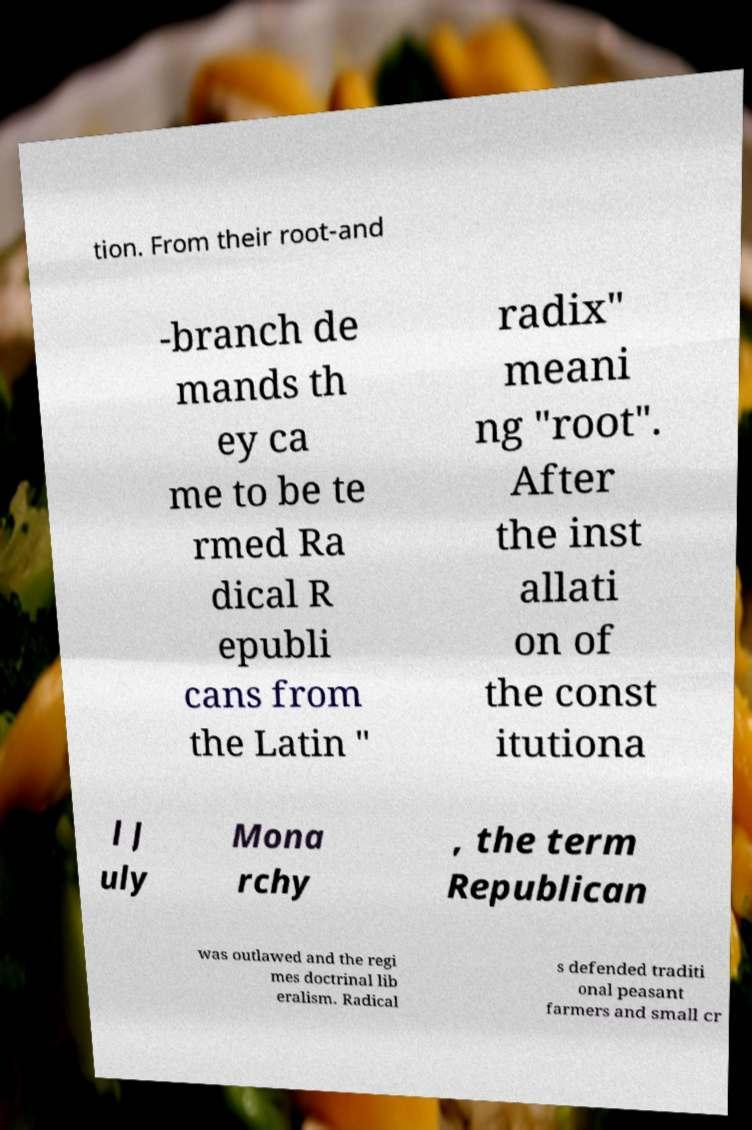There's text embedded in this image that I need extracted. Can you transcribe it verbatim? tion. From their root-and -branch de mands th ey ca me to be te rmed Ra dical R epubli cans from the Latin " radix" meani ng "root". After the inst allati on of the const itutiona l J uly Mona rchy , the term Republican was outlawed and the regi mes doctrinal lib eralism. Radical s defended traditi onal peasant farmers and small cr 